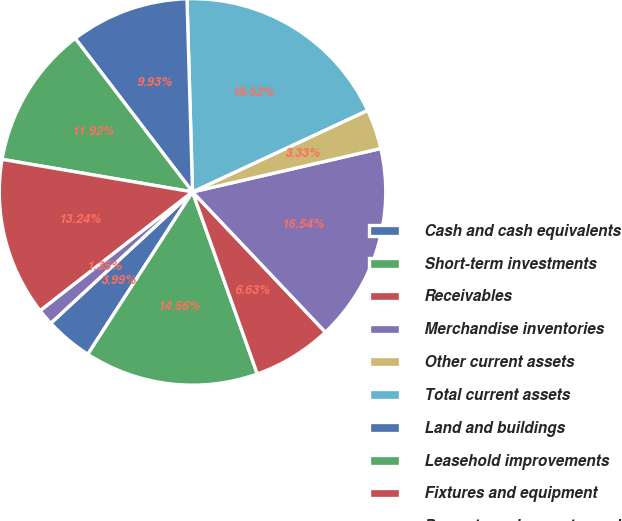<chart> <loc_0><loc_0><loc_500><loc_500><pie_chart><fcel>Cash and cash equivalents<fcel>Short-term investments<fcel>Receivables<fcel>Merchandise inventories<fcel>Other current assets<fcel>Total current assets<fcel>Land and buildings<fcel>Leasehold improvements<fcel>Fixtures and equipment<fcel>Property under master and<nl><fcel>3.99%<fcel>14.56%<fcel>6.63%<fcel>16.54%<fcel>3.33%<fcel>18.52%<fcel>9.93%<fcel>11.92%<fcel>13.24%<fcel>1.35%<nl></chart> 